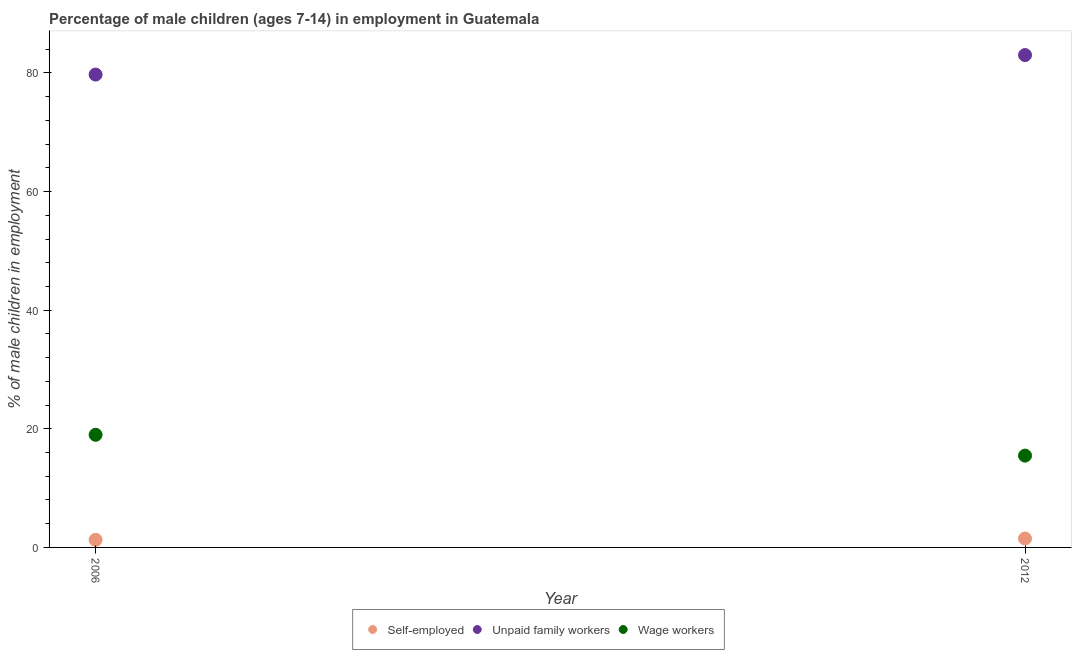How many different coloured dotlines are there?
Keep it short and to the point. 3. What is the percentage of children employed as wage workers in 2012?
Your answer should be very brief. 15.48. Across all years, what is the maximum percentage of children employed as wage workers?
Offer a terse response. 18.99. Across all years, what is the minimum percentage of children employed as unpaid family workers?
Offer a terse response. 79.73. In which year was the percentage of children employed as unpaid family workers minimum?
Your response must be concise. 2006. What is the total percentage of self employed children in the graph?
Make the answer very short. 2.78. What is the difference between the percentage of children employed as wage workers in 2006 and that in 2012?
Make the answer very short. 3.51. What is the difference between the percentage of children employed as unpaid family workers in 2006 and the percentage of children employed as wage workers in 2012?
Your response must be concise. 64.25. What is the average percentage of children employed as unpaid family workers per year?
Your response must be concise. 81.38. In the year 2006, what is the difference between the percentage of children employed as unpaid family workers and percentage of children employed as wage workers?
Your answer should be compact. 60.74. What is the ratio of the percentage of children employed as unpaid family workers in 2006 to that in 2012?
Offer a very short reply. 0.96. Does the percentage of children employed as wage workers monotonically increase over the years?
Offer a very short reply. No. Does the graph contain grids?
Offer a terse response. No. How many legend labels are there?
Keep it short and to the point. 3. What is the title of the graph?
Your answer should be compact. Percentage of male children (ages 7-14) in employment in Guatemala. Does "Primary" appear as one of the legend labels in the graph?
Offer a very short reply. No. What is the label or title of the Y-axis?
Keep it short and to the point. % of male children in employment. What is the % of male children in employment of Self-employed in 2006?
Your response must be concise. 1.28. What is the % of male children in employment in Unpaid family workers in 2006?
Give a very brief answer. 79.73. What is the % of male children in employment of Wage workers in 2006?
Ensure brevity in your answer.  18.99. What is the % of male children in employment of Unpaid family workers in 2012?
Provide a short and direct response. 83.02. What is the % of male children in employment in Wage workers in 2012?
Your answer should be very brief. 15.48. Across all years, what is the maximum % of male children in employment in Unpaid family workers?
Ensure brevity in your answer.  83.02. Across all years, what is the maximum % of male children in employment in Wage workers?
Provide a succinct answer. 18.99. Across all years, what is the minimum % of male children in employment of Self-employed?
Your answer should be very brief. 1.28. Across all years, what is the minimum % of male children in employment of Unpaid family workers?
Your answer should be very brief. 79.73. Across all years, what is the minimum % of male children in employment in Wage workers?
Your answer should be compact. 15.48. What is the total % of male children in employment in Self-employed in the graph?
Keep it short and to the point. 2.78. What is the total % of male children in employment of Unpaid family workers in the graph?
Offer a terse response. 162.75. What is the total % of male children in employment in Wage workers in the graph?
Provide a succinct answer. 34.47. What is the difference between the % of male children in employment of Self-employed in 2006 and that in 2012?
Offer a terse response. -0.22. What is the difference between the % of male children in employment in Unpaid family workers in 2006 and that in 2012?
Offer a very short reply. -3.29. What is the difference between the % of male children in employment in Wage workers in 2006 and that in 2012?
Give a very brief answer. 3.51. What is the difference between the % of male children in employment in Self-employed in 2006 and the % of male children in employment in Unpaid family workers in 2012?
Give a very brief answer. -81.74. What is the difference between the % of male children in employment of Unpaid family workers in 2006 and the % of male children in employment of Wage workers in 2012?
Give a very brief answer. 64.25. What is the average % of male children in employment in Self-employed per year?
Give a very brief answer. 1.39. What is the average % of male children in employment of Unpaid family workers per year?
Your answer should be very brief. 81.38. What is the average % of male children in employment in Wage workers per year?
Your answer should be compact. 17.23. In the year 2006, what is the difference between the % of male children in employment of Self-employed and % of male children in employment of Unpaid family workers?
Give a very brief answer. -78.45. In the year 2006, what is the difference between the % of male children in employment of Self-employed and % of male children in employment of Wage workers?
Keep it short and to the point. -17.71. In the year 2006, what is the difference between the % of male children in employment of Unpaid family workers and % of male children in employment of Wage workers?
Make the answer very short. 60.74. In the year 2012, what is the difference between the % of male children in employment of Self-employed and % of male children in employment of Unpaid family workers?
Offer a terse response. -81.52. In the year 2012, what is the difference between the % of male children in employment in Self-employed and % of male children in employment in Wage workers?
Provide a short and direct response. -13.98. In the year 2012, what is the difference between the % of male children in employment in Unpaid family workers and % of male children in employment in Wage workers?
Provide a short and direct response. 67.54. What is the ratio of the % of male children in employment in Self-employed in 2006 to that in 2012?
Offer a terse response. 0.85. What is the ratio of the % of male children in employment in Unpaid family workers in 2006 to that in 2012?
Your answer should be very brief. 0.96. What is the ratio of the % of male children in employment of Wage workers in 2006 to that in 2012?
Make the answer very short. 1.23. What is the difference between the highest and the second highest % of male children in employment of Self-employed?
Keep it short and to the point. 0.22. What is the difference between the highest and the second highest % of male children in employment of Unpaid family workers?
Your response must be concise. 3.29. What is the difference between the highest and the second highest % of male children in employment of Wage workers?
Your answer should be very brief. 3.51. What is the difference between the highest and the lowest % of male children in employment of Self-employed?
Ensure brevity in your answer.  0.22. What is the difference between the highest and the lowest % of male children in employment of Unpaid family workers?
Offer a terse response. 3.29. What is the difference between the highest and the lowest % of male children in employment of Wage workers?
Offer a very short reply. 3.51. 